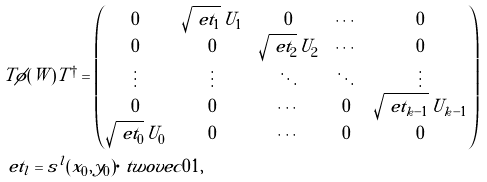<formula> <loc_0><loc_0><loc_500><loc_500>& T \phi ( W ) T ^ { \dagger } = \begin{pmatrix} 0 & \sqrt { \ e t _ { 1 } } \, U _ { 1 } & 0 & \cdots & 0 \\ 0 & 0 & \sqrt { \ e t _ { 2 } } \, U _ { 2 } & \cdots & 0 \\ \vdots & \vdots & \ddots & \ddots & \vdots \\ 0 & 0 & \cdots & 0 & \sqrt { \ e t _ { k - 1 } } \, U _ { k - 1 } \\ \sqrt { \ e t _ { 0 } } \, U _ { 0 } & 0 & \cdots & 0 & 0 \end{pmatrix} \\ & \ e t _ { l } = s ^ { l } ( x _ { 0 } , y _ { 0 } ) \cdot \ t w o v e c { 0 } { 1 } ,</formula> 